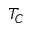<formula> <loc_0><loc_0><loc_500><loc_500>T _ { C }</formula> 